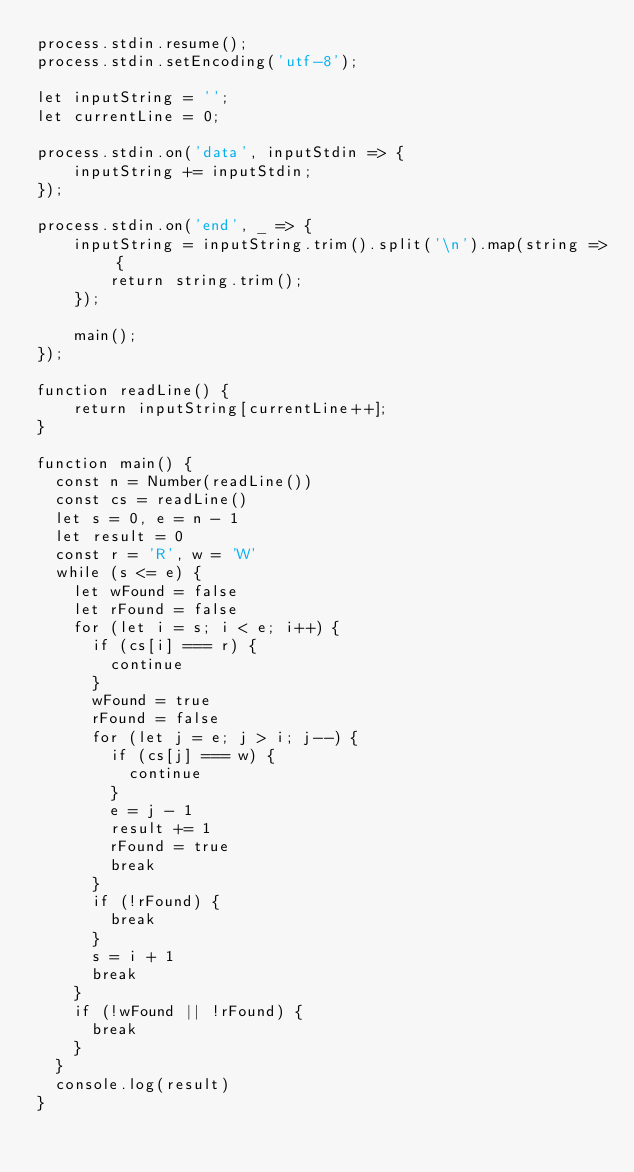<code> <loc_0><loc_0><loc_500><loc_500><_JavaScript_>process.stdin.resume();
process.stdin.setEncoding('utf-8');
 
let inputString = '';
let currentLine = 0;
 
process.stdin.on('data', inputStdin => {
    inputString += inputStdin;
});
 
process.stdin.on('end', _ => {
    inputString = inputString.trim().split('\n').map(string => {
        return string.trim();
    });
    
    main();    
});
 
function readLine() {
    return inputString[currentLine++];
}

function main() {
  const n = Number(readLine())
  const cs = readLine()
  let s = 0, e = n - 1
  let result = 0
  const r = 'R', w = 'W'
  while (s <= e) {
    let wFound = false
    let rFound = false
    for (let i = s; i < e; i++) {
      if (cs[i] === r) {
        continue
      }
      wFound = true
      rFound = false
      for (let j = e; j > i; j--) {
        if (cs[j] === w) {
          continue
        }
        e = j - 1
        result += 1
        rFound = true
        break
      }
      if (!rFound) {
        break
      }
      s = i + 1
      break
    }
    if (!wFound || !rFound) {
      break
    }
  }
  console.log(result)
}
</code> 